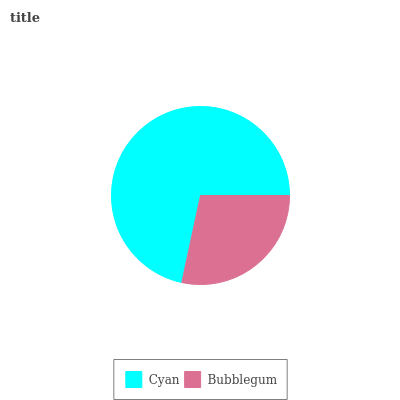Is Bubblegum the minimum?
Answer yes or no. Yes. Is Cyan the maximum?
Answer yes or no. Yes. Is Bubblegum the maximum?
Answer yes or no. No. Is Cyan greater than Bubblegum?
Answer yes or no. Yes. Is Bubblegum less than Cyan?
Answer yes or no. Yes. Is Bubblegum greater than Cyan?
Answer yes or no. No. Is Cyan less than Bubblegum?
Answer yes or no. No. Is Cyan the high median?
Answer yes or no. Yes. Is Bubblegum the low median?
Answer yes or no. Yes. Is Bubblegum the high median?
Answer yes or no. No. Is Cyan the low median?
Answer yes or no. No. 